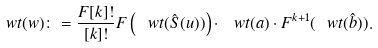<formula> <loc_0><loc_0><loc_500><loc_500>\ w t ( w ) \colon = \frac { F [ k ] ! } { [ k ] ! } F \left ( \ w t ( \hat { S } ( u ) ) \right ) \cdot \ w t ( a ) \cdot F ^ { k + 1 } ( \ w t ( \hat { b } ) ) .</formula> 